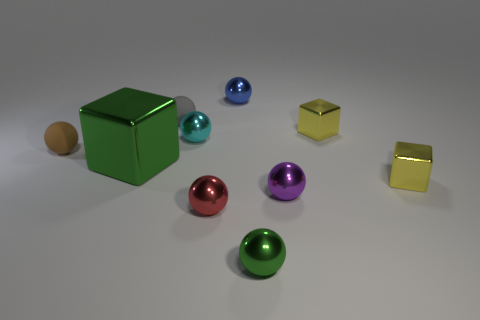What number of large shiny cubes are right of the purple ball?
Provide a short and direct response. 0. Are there any red metallic objects of the same size as the gray matte ball?
Offer a terse response. Yes. Is there another rubber thing that has the same color as the big object?
Provide a succinct answer. No. Are there any other things that are the same size as the gray thing?
Your response must be concise. Yes. What number of metal cubes have the same color as the big shiny object?
Ensure brevity in your answer.  0. There is a big object; is it the same color as the small ball that is in front of the red sphere?
Make the answer very short. Yes. How many objects are big green cubes or small metallic spheres in front of the blue thing?
Provide a short and direct response. 5. There is a green shiny object on the left side of the ball behind the tiny gray rubber object; what size is it?
Keep it short and to the point. Large. Are there the same number of purple spheres that are in front of the purple shiny object and tiny red objects to the left of the tiny cyan metal sphere?
Provide a short and direct response. Yes. Are there any yellow cubes behind the shiny cube that is on the left side of the small blue sphere?
Your answer should be very brief. Yes. 